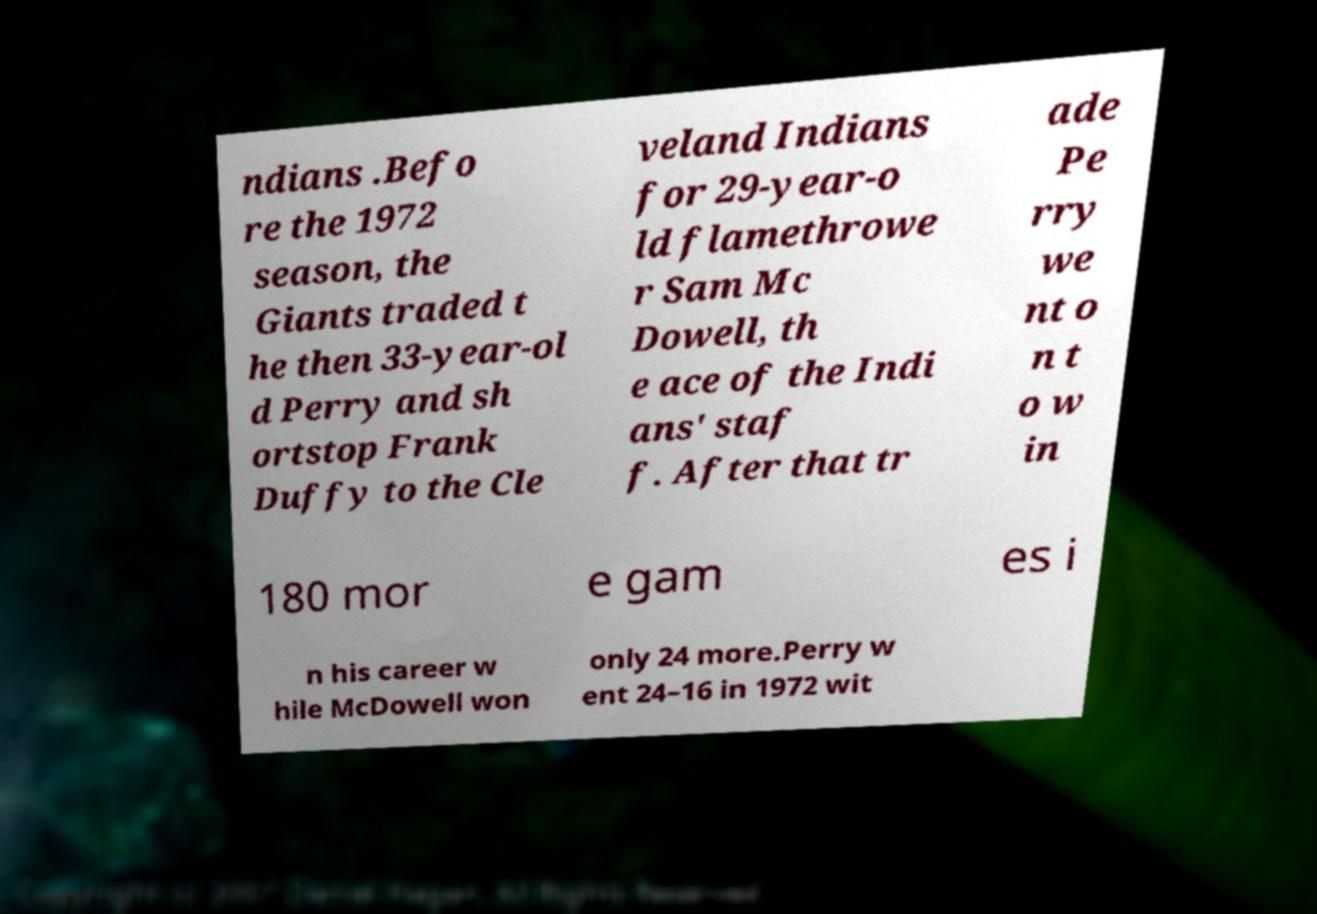Could you extract and type out the text from this image? ndians .Befo re the 1972 season, the Giants traded t he then 33-year-ol d Perry and sh ortstop Frank Duffy to the Cle veland Indians for 29-year-o ld flamethrowe r Sam Mc Dowell, th e ace of the Indi ans' staf f. After that tr ade Pe rry we nt o n t o w in 180 mor e gam es i n his career w hile McDowell won only 24 more.Perry w ent 24–16 in 1972 wit 